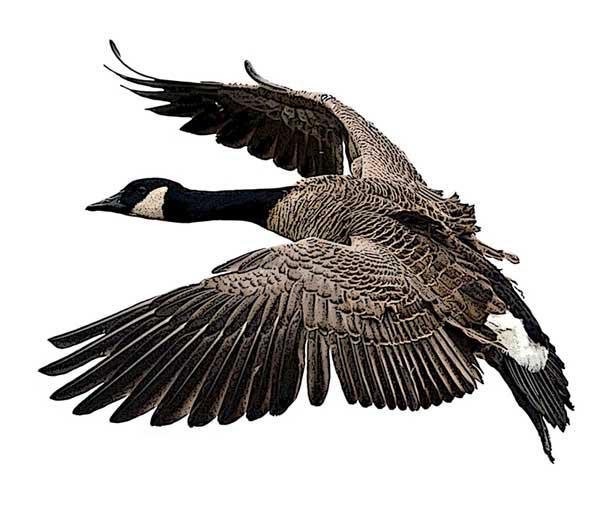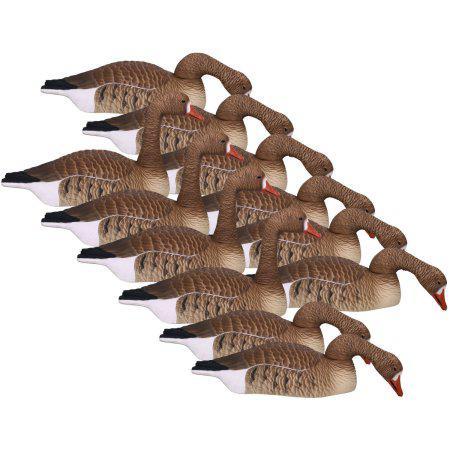The first image is the image on the left, the second image is the image on the right. Given the left and right images, does the statement "The geese in one image have dark orange beaks." hold true? Answer yes or no. Yes. The first image is the image on the left, the second image is the image on the right. Examine the images to the left and right. Is the description "All geese have flat bases without legs, black necks, and folded wings." accurate? Answer yes or no. No. 